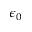<formula> <loc_0><loc_0><loc_500><loc_500>\epsilon _ { 0 }</formula> 